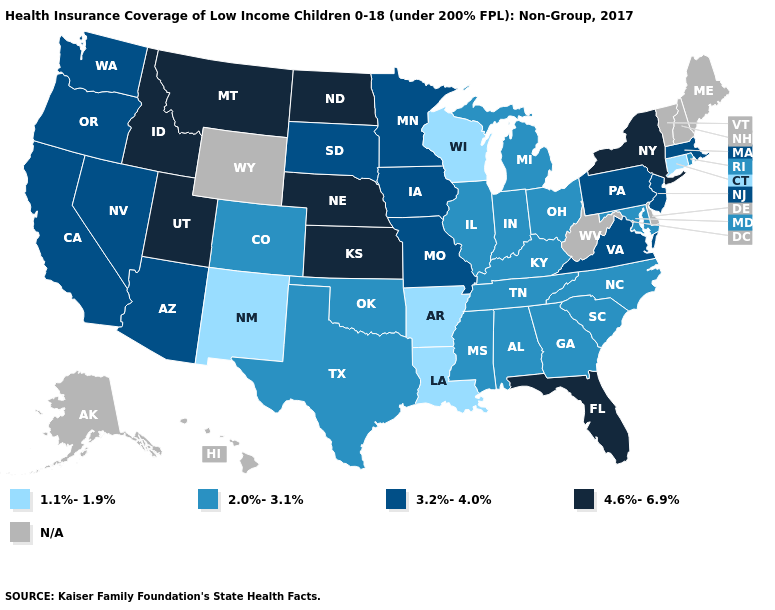What is the value of Connecticut?
Concise answer only. 1.1%-1.9%. What is the highest value in the Northeast ?
Quick response, please. 4.6%-6.9%. Name the states that have a value in the range 3.2%-4.0%?
Answer briefly. Arizona, California, Iowa, Massachusetts, Minnesota, Missouri, Nevada, New Jersey, Oregon, Pennsylvania, South Dakota, Virginia, Washington. What is the highest value in the USA?
Concise answer only. 4.6%-6.9%. Which states have the lowest value in the MidWest?
Write a very short answer. Wisconsin. What is the value of Connecticut?
Answer briefly. 1.1%-1.9%. Is the legend a continuous bar?
Answer briefly. No. Among the states that border Oregon , does Idaho have the lowest value?
Short answer required. No. What is the value of North Carolina?
Short answer required. 2.0%-3.1%. Does the first symbol in the legend represent the smallest category?
Answer briefly. Yes. What is the value of New York?
Answer briefly. 4.6%-6.9%. What is the value of New York?
Give a very brief answer. 4.6%-6.9%. What is the lowest value in the USA?
Answer briefly. 1.1%-1.9%. What is the value of California?
Write a very short answer. 3.2%-4.0%. 